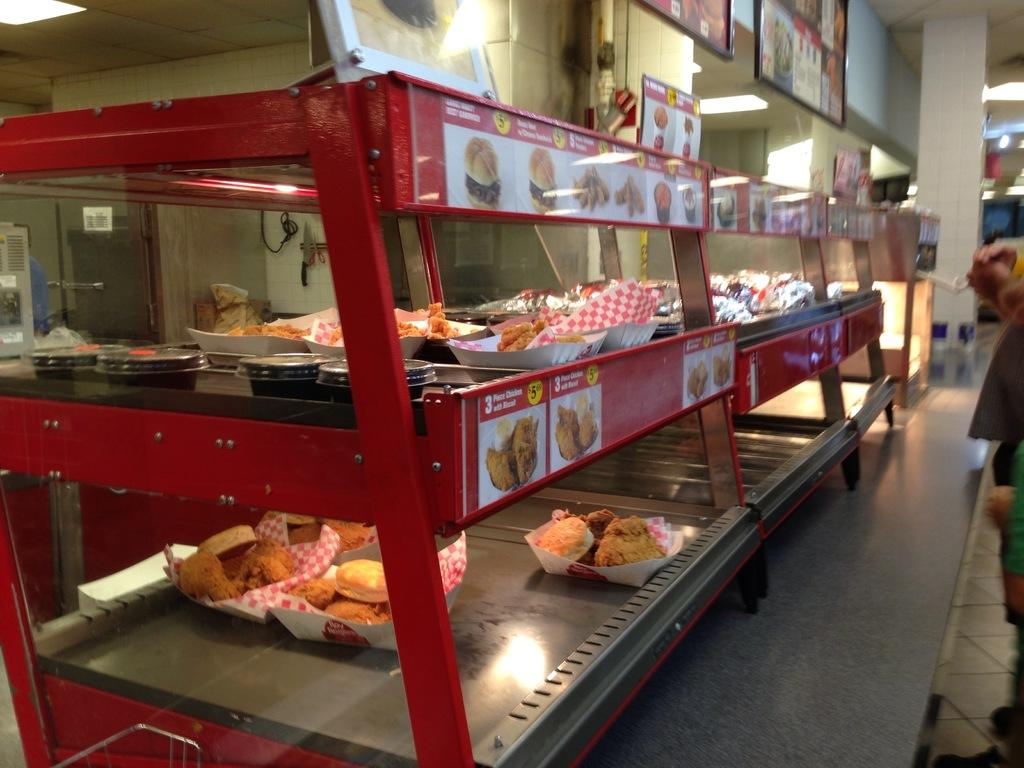What type of food items can be seen in the image? There are sweets in the image. What appliance is present in the image? There is a refrigerator in the image. What object is used for displaying photos in the image? There is a photo frame in the image. What type of structure is visible in the image? There is a wall in the image. How do the brothers interact with each other in the image? There are no brothers present in the image; it only features sweets, a refrigerator, a photo frame, and a wall. What type of friction can be observed between the sweets and the refrigerator in the image? There is no friction between the sweets and the refrigerator in the image, as they are separate objects and not interacting with each other. 